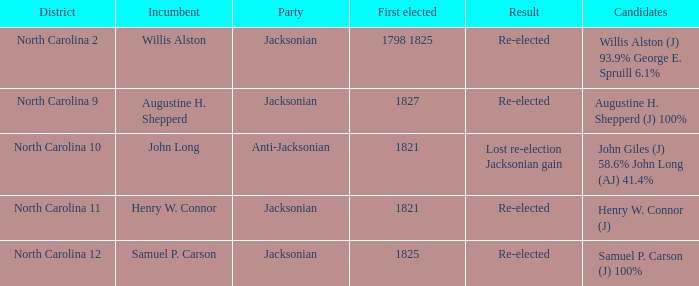Name the result for first elected being 1798 1825 Re-elected. 